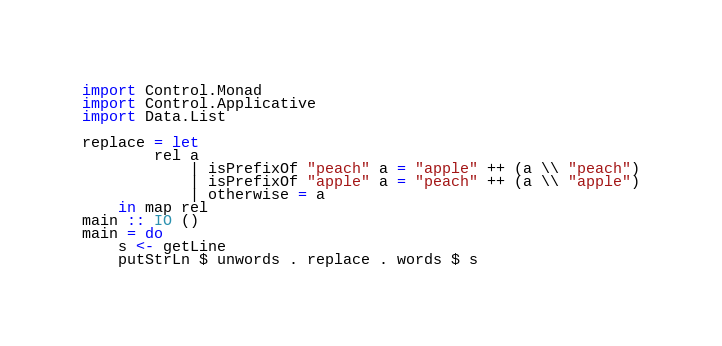Convert code to text. <code><loc_0><loc_0><loc_500><loc_500><_Haskell_>import Control.Monad
import Control.Applicative
import Data.List

replace = let 
        rel a
            | isPrefixOf "peach" a = "apple" ++ (a \\ "peach")
            | isPrefixOf "apple" a = "peach" ++ (a \\ "apple")
            | otherwise = a
    in map rel
main :: IO ()
main = do
    s <- getLine
    putStrLn $ unwords . replace . words $ s

</code> 